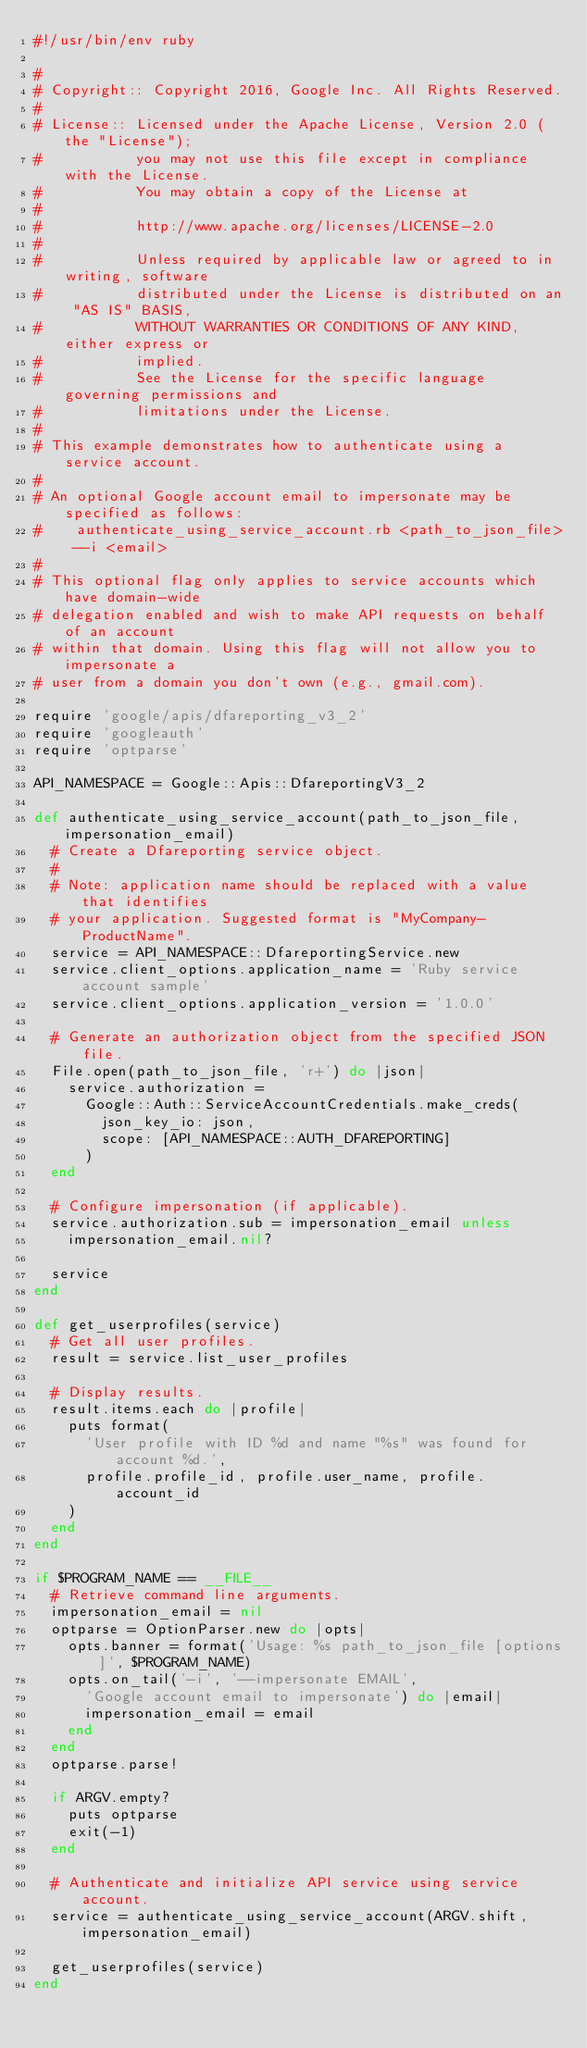Convert code to text. <code><loc_0><loc_0><loc_500><loc_500><_Ruby_>#!/usr/bin/env ruby

#
# Copyright:: Copyright 2016, Google Inc. All Rights Reserved.
#
# License:: Licensed under the Apache License, Version 2.0 (the "License");
#           you may not use this file except in compliance with the License.
#           You may obtain a copy of the License at
#
#           http://www.apache.org/licenses/LICENSE-2.0
#
#           Unless required by applicable law or agreed to in writing, software
#           distributed under the License is distributed on an "AS IS" BASIS,
#           WITHOUT WARRANTIES OR CONDITIONS OF ANY KIND, either express or
#           implied.
#           See the License for the specific language governing permissions and
#           limitations under the License.
#
# This example demonstrates how to authenticate using a service account.
#
# An optional Google account email to impersonate may be specified as follows:
#    authenticate_using_service_account.rb <path_to_json_file> --i <email>
#
# This optional flag only applies to service accounts which have domain-wide
# delegation enabled and wish to make API requests on behalf of an account
# within that domain. Using this flag will not allow you to impersonate a
# user from a domain you don't own (e.g., gmail.com).

require 'google/apis/dfareporting_v3_2'
require 'googleauth'
require 'optparse'

API_NAMESPACE = Google::Apis::DfareportingV3_2

def authenticate_using_service_account(path_to_json_file, impersonation_email)
  # Create a Dfareporting service object.
  #
  # Note: application name should be replaced with a value that identifies
  # your application. Suggested format is "MyCompany-ProductName".
  service = API_NAMESPACE::DfareportingService.new
  service.client_options.application_name = 'Ruby service account sample'
  service.client_options.application_version = '1.0.0'

  # Generate an authorization object from the specified JSON file.
  File.open(path_to_json_file, 'r+') do |json|
    service.authorization =
      Google::Auth::ServiceAccountCredentials.make_creds(
        json_key_io: json,
        scope: [API_NAMESPACE::AUTH_DFAREPORTING]
      )
  end

  # Configure impersonation (if applicable).
  service.authorization.sub = impersonation_email unless
    impersonation_email.nil?

  service
end

def get_userprofiles(service)
  # Get all user profiles.
  result = service.list_user_profiles

  # Display results.
  result.items.each do |profile|
    puts format(
      'User profile with ID %d and name "%s" was found for account %d.',
      profile.profile_id, profile.user_name, profile.account_id
    )
  end
end

if $PROGRAM_NAME == __FILE__
  # Retrieve command line arguments.
  impersonation_email = nil
  optparse = OptionParser.new do |opts|
    opts.banner = format('Usage: %s path_to_json_file [options]', $PROGRAM_NAME)
    opts.on_tail('-i', '--impersonate EMAIL',
      'Google account email to impersonate') do |email|
      impersonation_email = email
    end
  end
  optparse.parse!

  if ARGV.empty?
    puts optparse
    exit(-1)
  end

  # Authenticate and initialize API service using service account.
  service = authenticate_using_service_account(ARGV.shift, impersonation_email)

  get_userprofiles(service)
end
</code> 